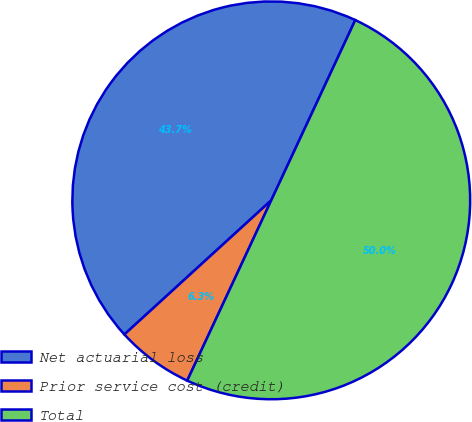Convert chart. <chart><loc_0><loc_0><loc_500><loc_500><pie_chart><fcel>Net actuarial loss<fcel>Prior service cost (credit)<fcel>Total<nl><fcel>43.72%<fcel>6.28%<fcel>50.0%<nl></chart> 